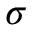<formula> <loc_0><loc_0><loc_500><loc_500>\sigma</formula> 